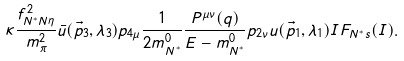<formula> <loc_0><loc_0><loc_500><loc_500>\kappa \frac { f _ { N ^ { * } N \eta } ^ { 2 } } { m _ { \pi } ^ { 2 } } \bar { u } ( \vec { p } _ { 3 } , \lambda _ { 3 } ) p _ { 4 \mu } \frac { 1 } { 2 m ^ { 0 } _ { N ^ { * } } } \frac { P ^ { \mu \nu } ( q ) } { E - m ^ { 0 } _ { N ^ { * } } } p _ { 2 \nu } u ( \vec { p } _ { 1 } , \lambda _ { 1 } ) I F _ { N ^ { * } s } ( I ) .</formula> 